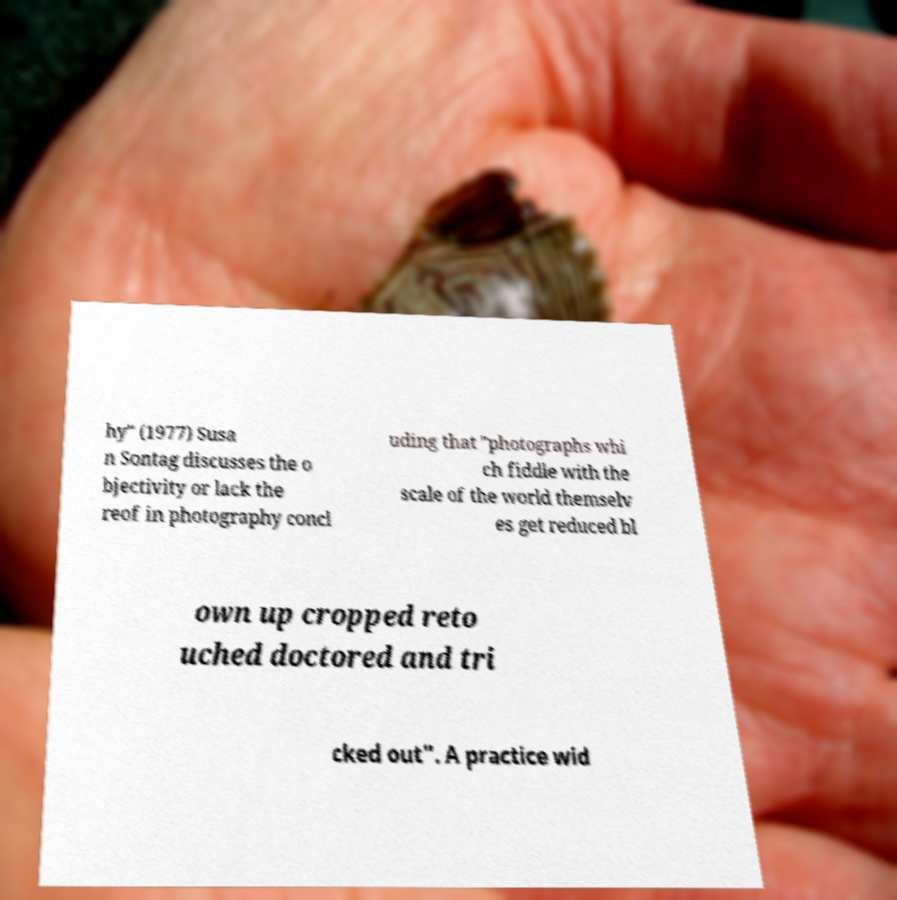There's text embedded in this image that I need extracted. Can you transcribe it verbatim? hy" (1977) Susa n Sontag discusses the o bjectivity or lack the reof in photography concl uding that "photographs whi ch fiddle with the scale of the world themselv es get reduced bl own up cropped reto uched doctored and tri cked out". A practice wid 